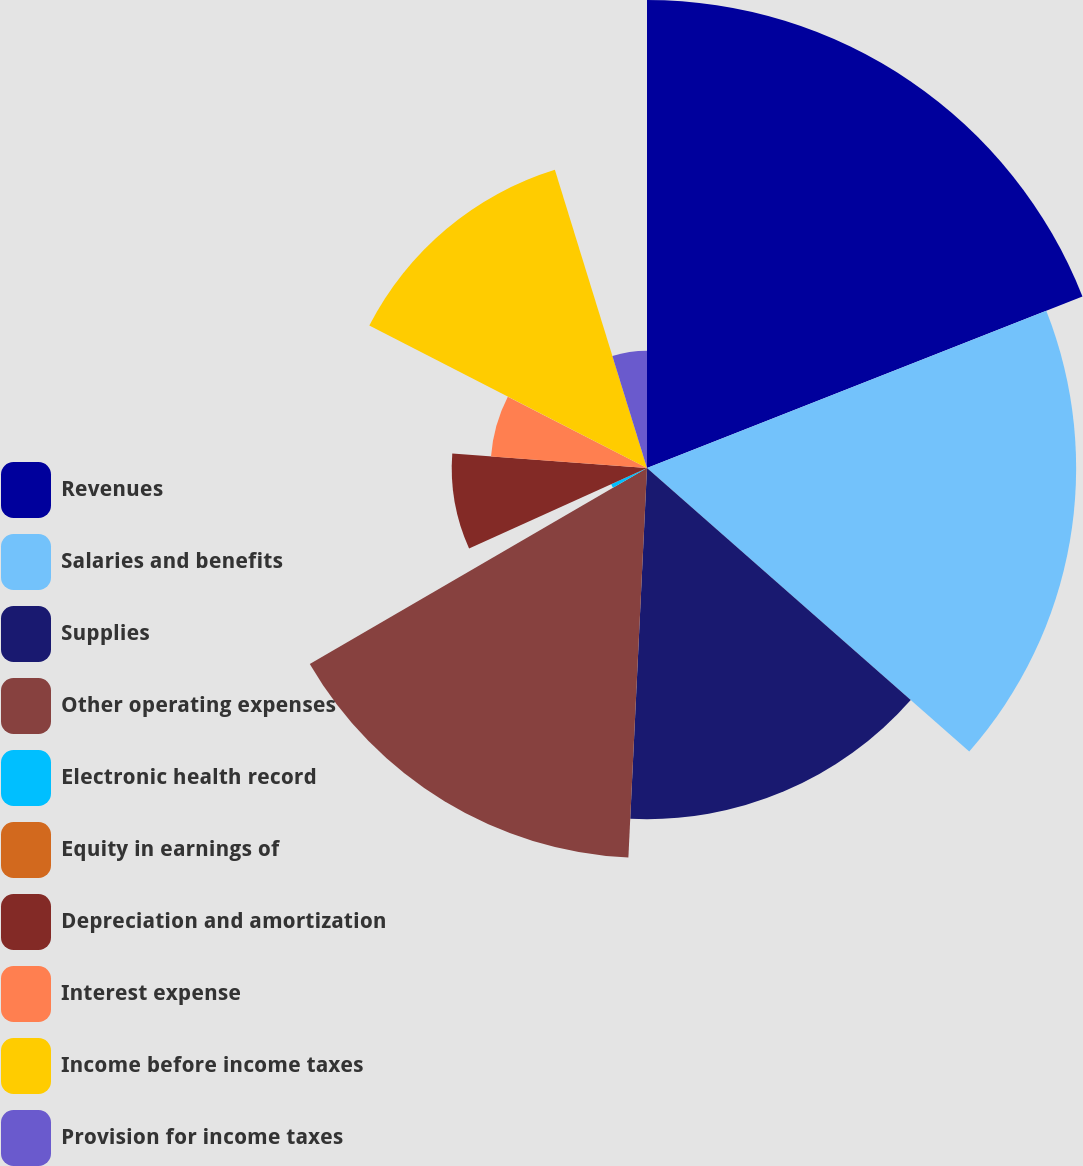Convert chart to OTSL. <chart><loc_0><loc_0><loc_500><loc_500><pie_chart><fcel>Revenues<fcel>Salaries and benefits<fcel>Supplies<fcel>Other operating expenses<fcel>Electronic health record<fcel>Equity in earnings of<fcel>Depreciation and amortization<fcel>Interest expense<fcel>Income before income taxes<fcel>Provision for income taxes<nl><fcel>19.03%<fcel>17.45%<fcel>14.28%<fcel>15.86%<fcel>1.6%<fcel>0.02%<fcel>7.94%<fcel>6.36%<fcel>12.69%<fcel>4.77%<nl></chart> 